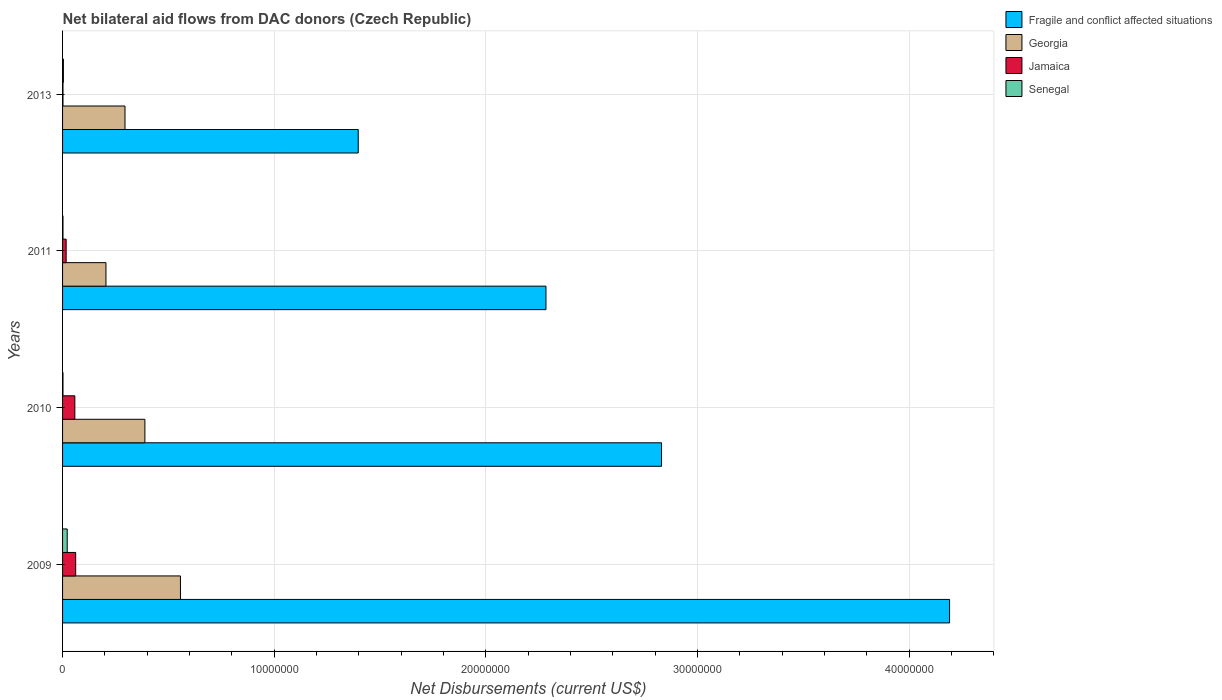How many groups of bars are there?
Provide a succinct answer. 4. How many bars are there on the 1st tick from the bottom?
Provide a short and direct response. 4. In how many cases, is the number of bars for a given year not equal to the number of legend labels?
Keep it short and to the point. 0. What is the net bilateral aid flows in Senegal in 2010?
Ensure brevity in your answer.  2.00e+04. Across all years, what is the maximum net bilateral aid flows in Fragile and conflict affected situations?
Your response must be concise. 4.19e+07. In which year was the net bilateral aid flows in Jamaica maximum?
Ensure brevity in your answer.  2009. In which year was the net bilateral aid flows in Jamaica minimum?
Your response must be concise. 2013. What is the total net bilateral aid flows in Georgia in the graph?
Give a very brief answer. 1.45e+07. What is the difference between the net bilateral aid flows in Senegal in 2009 and that in 2010?
Your answer should be compact. 2.00e+05. What is the difference between the net bilateral aid flows in Senegal in 2010 and the net bilateral aid flows in Fragile and conflict affected situations in 2013?
Provide a succinct answer. -1.40e+07. What is the average net bilateral aid flows in Georgia per year?
Keep it short and to the point. 3.62e+06. Is the difference between the net bilateral aid flows in Jamaica in 2009 and 2011 greater than the difference between the net bilateral aid flows in Senegal in 2009 and 2011?
Offer a very short reply. Yes. What is the difference between the highest and the second highest net bilateral aid flows in Fragile and conflict affected situations?
Offer a terse response. 1.36e+07. What is the difference between the highest and the lowest net bilateral aid flows in Fragile and conflict affected situations?
Give a very brief answer. 2.79e+07. In how many years, is the net bilateral aid flows in Georgia greater than the average net bilateral aid flows in Georgia taken over all years?
Provide a succinct answer. 2. Is the sum of the net bilateral aid flows in Fragile and conflict affected situations in 2010 and 2013 greater than the maximum net bilateral aid flows in Georgia across all years?
Give a very brief answer. Yes. Is it the case that in every year, the sum of the net bilateral aid flows in Fragile and conflict affected situations and net bilateral aid flows in Senegal is greater than the sum of net bilateral aid flows in Georgia and net bilateral aid flows in Jamaica?
Offer a terse response. Yes. What does the 3rd bar from the top in 2010 represents?
Ensure brevity in your answer.  Georgia. What does the 3rd bar from the bottom in 2009 represents?
Make the answer very short. Jamaica. Does the graph contain any zero values?
Ensure brevity in your answer.  No. How many legend labels are there?
Offer a very short reply. 4. How are the legend labels stacked?
Ensure brevity in your answer.  Vertical. What is the title of the graph?
Provide a succinct answer. Net bilateral aid flows from DAC donors (Czech Republic). Does "Middle East & North Africa (developing only)" appear as one of the legend labels in the graph?
Make the answer very short. No. What is the label or title of the X-axis?
Offer a very short reply. Net Disbursements (current US$). What is the label or title of the Y-axis?
Your answer should be compact. Years. What is the Net Disbursements (current US$) of Fragile and conflict affected situations in 2009?
Keep it short and to the point. 4.19e+07. What is the Net Disbursements (current US$) of Georgia in 2009?
Your answer should be compact. 5.57e+06. What is the Net Disbursements (current US$) of Jamaica in 2009?
Keep it short and to the point. 6.20e+05. What is the Net Disbursements (current US$) of Senegal in 2009?
Ensure brevity in your answer.  2.20e+05. What is the Net Disbursements (current US$) in Fragile and conflict affected situations in 2010?
Offer a terse response. 2.83e+07. What is the Net Disbursements (current US$) in Georgia in 2010?
Offer a terse response. 3.89e+06. What is the Net Disbursements (current US$) of Jamaica in 2010?
Your answer should be compact. 5.80e+05. What is the Net Disbursements (current US$) in Fragile and conflict affected situations in 2011?
Ensure brevity in your answer.  2.28e+07. What is the Net Disbursements (current US$) in Georgia in 2011?
Give a very brief answer. 2.05e+06. What is the Net Disbursements (current US$) in Jamaica in 2011?
Ensure brevity in your answer.  1.70e+05. What is the Net Disbursements (current US$) in Senegal in 2011?
Your response must be concise. 2.00e+04. What is the Net Disbursements (current US$) of Fragile and conflict affected situations in 2013?
Give a very brief answer. 1.40e+07. What is the Net Disbursements (current US$) in Georgia in 2013?
Ensure brevity in your answer.  2.95e+06. What is the Net Disbursements (current US$) in Jamaica in 2013?
Your response must be concise. 2.00e+04. What is the Net Disbursements (current US$) in Senegal in 2013?
Provide a short and direct response. 4.00e+04. Across all years, what is the maximum Net Disbursements (current US$) of Fragile and conflict affected situations?
Make the answer very short. 4.19e+07. Across all years, what is the maximum Net Disbursements (current US$) of Georgia?
Provide a succinct answer. 5.57e+06. Across all years, what is the maximum Net Disbursements (current US$) in Jamaica?
Give a very brief answer. 6.20e+05. Across all years, what is the maximum Net Disbursements (current US$) in Senegal?
Provide a succinct answer. 2.20e+05. Across all years, what is the minimum Net Disbursements (current US$) of Fragile and conflict affected situations?
Your answer should be compact. 1.40e+07. Across all years, what is the minimum Net Disbursements (current US$) in Georgia?
Provide a short and direct response. 2.05e+06. Across all years, what is the minimum Net Disbursements (current US$) of Senegal?
Your answer should be compact. 2.00e+04. What is the total Net Disbursements (current US$) in Fragile and conflict affected situations in the graph?
Offer a very short reply. 1.07e+08. What is the total Net Disbursements (current US$) in Georgia in the graph?
Your response must be concise. 1.45e+07. What is the total Net Disbursements (current US$) of Jamaica in the graph?
Offer a very short reply. 1.39e+06. What is the difference between the Net Disbursements (current US$) in Fragile and conflict affected situations in 2009 and that in 2010?
Offer a terse response. 1.36e+07. What is the difference between the Net Disbursements (current US$) in Georgia in 2009 and that in 2010?
Offer a very short reply. 1.68e+06. What is the difference between the Net Disbursements (current US$) in Fragile and conflict affected situations in 2009 and that in 2011?
Ensure brevity in your answer.  1.91e+07. What is the difference between the Net Disbursements (current US$) in Georgia in 2009 and that in 2011?
Offer a very short reply. 3.52e+06. What is the difference between the Net Disbursements (current US$) in Fragile and conflict affected situations in 2009 and that in 2013?
Provide a succinct answer. 2.79e+07. What is the difference between the Net Disbursements (current US$) in Georgia in 2009 and that in 2013?
Provide a short and direct response. 2.62e+06. What is the difference between the Net Disbursements (current US$) in Senegal in 2009 and that in 2013?
Offer a very short reply. 1.80e+05. What is the difference between the Net Disbursements (current US$) of Fragile and conflict affected situations in 2010 and that in 2011?
Your answer should be very brief. 5.46e+06. What is the difference between the Net Disbursements (current US$) in Georgia in 2010 and that in 2011?
Provide a succinct answer. 1.84e+06. What is the difference between the Net Disbursements (current US$) in Senegal in 2010 and that in 2011?
Give a very brief answer. 0. What is the difference between the Net Disbursements (current US$) in Fragile and conflict affected situations in 2010 and that in 2013?
Offer a terse response. 1.43e+07. What is the difference between the Net Disbursements (current US$) of Georgia in 2010 and that in 2013?
Give a very brief answer. 9.40e+05. What is the difference between the Net Disbursements (current US$) of Jamaica in 2010 and that in 2013?
Provide a succinct answer. 5.60e+05. What is the difference between the Net Disbursements (current US$) in Fragile and conflict affected situations in 2011 and that in 2013?
Make the answer very short. 8.87e+06. What is the difference between the Net Disbursements (current US$) of Georgia in 2011 and that in 2013?
Keep it short and to the point. -9.00e+05. What is the difference between the Net Disbursements (current US$) in Fragile and conflict affected situations in 2009 and the Net Disbursements (current US$) in Georgia in 2010?
Ensure brevity in your answer.  3.80e+07. What is the difference between the Net Disbursements (current US$) of Fragile and conflict affected situations in 2009 and the Net Disbursements (current US$) of Jamaica in 2010?
Offer a terse response. 4.13e+07. What is the difference between the Net Disbursements (current US$) of Fragile and conflict affected situations in 2009 and the Net Disbursements (current US$) of Senegal in 2010?
Your answer should be very brief. 4.19e+07. What is the difference between the Net Disbursements (current US$) of Georgia in 2009 and the Net Disbursements (current US$) of Jamaica in 2010?
Keep it short and to the point. 4.99e+06. What is the difference between the Net Disbursements (current US$) of Georgia in 2009 and the Net Disbursements (current US$) of Senegal in 2010?
Offer a very short reply. 5.55e+06. What is the difference between the Net Disbursements (current US$) of Fragile and conflict affected situations in 2009 and the Net Disbursements (current US$) of Georgia in 2011?
Your answer should be very brief. 3.99e+07. What is the difference between the Net Disbursements (current US$) of Fragile and conflict affected situations in 2009 and the Net Disbursements (current US$) of Jamaica in 2011?
Provide a succinct answer. 4.17e+07. What is the difference between the Net Disbursements (current US$) in Fragile and conflict affected situations in 2009 and the Net Disbursements (current US$) in Senegal in 2011?
Provide a short and direct response. 4.19e+07. What is the difference between the Net Disbursements (current US$) in Georgia in 2009 and the Net Disbursements (current US$) in Jamaica in 2011?
Your response must be concise. 5.40e+06. What is the difference between the Net Disbursements (current US$) in Georgia in 2009 and the Net Disbursements (current US$) in Senegal in 2011?
Provide a succinct answer. 5.55e+06. What is the difference between the Net Disbursements (current US$) in Jamaica in 2009 and the Net Disbursements (current US$) in Senegal in 2011?
Your response must be concise. 6.00e+05. What is the difference between the Net Disbursements (current US$) in Fragile and conflict affected situations in 2009 and the Net Disbursements (current US$) in Georgia in 2013?
Keep it short and to the point. 3.90e+07. What is the difference between the Net Disbursements (current US$) in Fragile and conflict affected situations in 2009 and the Net Disbursements (current US$) in Jamaica in 2013?
Provide a short and direct response. 4.19e+07. What is the difference between the Net Disbursements (current US$) in Fragile and conflict affected situations in 2009 and the Net Disbursements (current US$) in Senegal in 2013?
Provide a succinct answer. 4.19e+07. What is the difference between the Net Disbursements (current US$) in Georgia in 2009 and the Net Disbursements (current US$) in Jamaica in 2013?
Give a very brief answer. 5.55e+06. What is the difference between the Net Disbursements (current US$) of Georgia in 2009 and the Net Disbursements (current US$) of Senegal in 2013?
Ensure brevity in your answer.  5.53e+06. What is the difference between the Net Disbursements (current US$) in Jamaica in 2009 and the Net Disbursements (current US$) in Senegal in 2013?
Provide a succinct answer. 5.80e+05. What is the difference between the Net Disbursements (current US$) in Fragile and conflict affected situations in 2010 and the Net Disbursements (current US$) in Georgia in 2011?
Ensure brevity in your answer.  2.62e+07. What is the difference between the Net Disbursements (current US$) in Fragile and conflict affected situations in 2010 and the Net Disbursements (current US$) in Jamaica in 2011?
Ensure brevity in your answer.  2.81e+07. What is the difference between the Net Disbursements (current US$) in Fragile and conflict affected situations in 2010 and the Net Disbursements (current US$) in Senegal in 2011?
Provide a short and direct response. 2.83e+07. What is the difference between the Net Disbursements (current US$) of Georgia in 2010 and the Net Disbursements (current US$) of Jamaica in 2011?
Your answer should be compact. 3.72e+06. What is the difference between the Net Disbursements (current US$) of Georgia in 2010 and the Net Disbursements (current US$) of Senegal in 2011?
Your answer should be very brief. 3.87e+06. What is the difference between the Net Disbursements (current US$) in Jamaica in 2010 and the Net Disbursements (current US$) in Senegal in 2011?
Keep it short and to the point. 5.60e+05. What is the difference between the Net Disbursements (current US$) of Fragile and conflict affected situations in 2010 and the Net Disbursements (current US$) of Georgia in 2013?
Provide a short and direct response. 2.54e+07. What is the difference between the Net Disbursements (current US$) in Fragile and conflict affected situations in 2010 and the Net Disbursements (current US$) in Jamaica in 2013?
Your response must be concise. 2.83e+07. What is the difference between the Net Disbursements (current US$) of Fragile and conflict affected situations in 2010 and the Net Disbursements (current US$) of Senegal in 2013?
Offer a terse response. 2.83e+07. What is the difference between the Net Disbursements (current US$) of Georgia in 2010 and the Net Disbursements (current US$) of Jamaica in 2013?
Offer a very short reply. 3.87e+06. What is the difference between the Net Disbursements (current US$) of Georgia in 2010 and the Net Disbursements (current US$) of Senegal in 2013?
Offer a terse response. 3.85e+06. What is the difference between the Net Disbursements (current US$) of Jamaica in 2010 and the Net Disbursements (current US$) of Senegal in 2013?
Give a very brief answer. 5.40e+05. What is the difference between the Net Disbursements (current US$) in Fragile and conflict affected situations in 2011 and the Net Disbursements (current US$) in Georgia in 2013?
Your answer should be compact. 1.99e+07. What is the difference between the Net Disbursements (current US$) of Fragile and conflict affected situations in 2011 and the Net Disbursements (current US$) of Jamaica in 2013?
Ensure brevity in your answer.  2.28e+07. What is the difference between the Net Disbursements (current US$) in Fragile and conflict affected situations in 2011 and the Net Disbursements (current US$) in Senegal in 2013?
Offer a terse response. 2.28e+07. What is the difference between the Net Disbursements (current US$) of Georgia in 2011 and the Net Disbursements (current US$) of Jamaica in 2013?
Provide a succinct answer. 2.03e+06. What is the difference between the Net Disbursements (current US$) in Georgia in 2011 and the Net Disbursements (current US$) in Senegal in 2013?
Make the answer very short. 2.01e+06. What is the average Net Disbursements (current US$) of Fragile and conflict affected situations per year?
Offer a terse response. 2.68e+07. What is the average Net Disbursements (current US$) in Georgia per year?
Your answer should be compact. 3.62e+06. What is the average Net Disbursements (current US$) in Jamaica per year?
Offer a very short reply. 3.48e+05. What is the average Net Disbursements (current US$) of Senegal per year?
Provide a short and direct response. 7.50e+04. In the year 2009, what is the difference between the Net Disbursements (current US$) in Fragile and conflict affected situations and Net Disbursements (current US$) in Georgia?
Ensure brevity in your answer.  3.63e+07. In the year 2009, what is the difference between the Net Disbursements (current US$) of Fragile and conflict affected situations and Net Disbursements (current US$) of Jamaica?
Provide a succinct answer. 4.13e+07. In the year 2009, what is the difference between the Net Disbursements (current US$) of Fragile and conflict affected situations and Net Disbursements (current US$) of Senegal?
Offer a very short reply. 4.17e+07. In the year 2009, what is the difference between the Net Disbursements (current US$) of Georgia and Net Disbursements (current US$) of Jamaica?
Make the answer very short. 4.95e+06. In the year 2009, what is the difference between the Net Disbursements (current US$) in Georgia and Net Disbursements (current US$) in Senegal?
Make the answer very short. 5.35e+06. In the year 2010, what is the difference between the Net Disbursements (current US$) in Fragile and conflict affected situations and Net Disbursements (current US$) in Georgia?
Provide a short and direct response. 2.44e+07. In the year 2010, what is the difference between the Net Disbursements (current US$) in Fragile and conflict affected situations and Net Disbursements (current US$) in Jamaica?
Ensure brevity in your answer.  2.77e+07. In the year 2010, what is the difference between the Net Disbursements (current US$) of Fragile and conflict affected situations and Net Disbursements (current US$) of Senegal?
Your response must be concise. 2.83e+07. In the year 2010, what is the difference between the Net Disbursements (current US$) of Georgia and Net Disbursements (current US$) of Jamaica?
Provide a short and direct response. 3.31e+06. In the year 2010, what is the difference between the Net Disbursements (current US$) in Georgia and Net Disbursements (current US$) in Senegal?
Provide a short and direct response. 3.87e+06. In the year 2010, what is the difference between the Net Disbursements (current US$) of Jamaica and Net Disbursements (current US$) of Senegal?
Give a very brief answer. 5.60e+05. In the year 2011, what is the difference between the Net Disbursements (current US$) of Fragile and conflict affected situations and Net Disbursements (current US$) of Georgia?
Your answer should be very brief. 2.08e+07. In the year 2011, what is the difference between the Net Disbursements (current US$) of Fragile and conflict affected situations and Net Disbursements (current US$) of Jamaica?
Your response must be concise. 2.27e+07. In the year 2011, what is the difference between the Net Disbursements (current US$) of Fragile and conflict affected situations and Net Disbursements (current US$) of Senegal?
Provide a succinct answer. 2.28e+07. In the year 2011, what is the difference between the Net Disbursements (current US$) in Georgia and Net Disbursements (current US$) in Jamaica?
Make the answer very short. 1.88e+06. In the year 2011, what is the difference between the Net Disbursements (current US$) in Georgia and Net Disbursements (current US$) in Senegal?
Your answer should be very brief. 2.03e+06. In the year 2013, what is the difference between the Net Disbursements (current US$) of Fragile and conflict affected situations and Net Disbursements (current US$) of Georgia?
Keep it short and to the point. 1.10e+07. In the year 2013, what is the difference between the Net Disbursements (current US$) of Fragile and conflict affected situations and Net Disbursements (current US$) of Jamaica?
Provide a succinct answer. 1.40e+07. In the year 2013, what is the difference between the Net Disbursements (current US$) in Fragile and conflict affected situations and Net Disbursements (current US$) in Senegal?
Your answer should be very brief. 1.39e+07. In the year 2013, what is the difference between the Net Disbursements (current US$) of Georgia and Net Disbursements (current US$) of Jamaica?
Give a very brief answer. 2.93e+06. In the year 2013, what is the difference between the Net Disbursements (current US$) of Georgia and Net Disbursements (current US$) of Senegal?
Provide a succinct answer. 2.91e+06. In the year 2013, what is the difference between the Net Disbursements (current US$) in Jamaica and Net Disbursements (current US$) in Senegal?
Provide a short and direct response. -2.00e+04. What is the ratio of the Net Disbursements (current US$) of Fragile and conflict affected situations in 2009 to that in 2010?
Your answer should be compact. 1.48. What is the ratio of the Net Disbursements (current US$) in Georgia in 2009 to that in 2010?
Your answer should be compact. 1.43. What is the ratio of the Net Disbursements (current US$) of Jamaica in 2009 to that in 2010?
Provide a short and direct response. 1.07. What is the ratio of the Net Disbursements (current US$) in Senegal in 2009 to that in 2010?
Keep it short and to the point. 11. What is the ratio of the Net Disbursements (current US$) of Fragile and conflict affected situations in 2009 to that in 2011?
Offer a terse response. 1.83. What is the ratio of the Net Disbursements (current US$) in Georgia in 2009 to that in 2011?
Offer a very short reply. 2.72. What is the ratio of the Net Disbursements (current US$) in Jamaica in 2009 to that in 2011?
Provide a succinct answer. 3.65. What is the ratio of the Net Disbursements (current US$) in Fragile and conflict affected situations in 2009 to that in 2013?
Offer a terse response. 3. What is the ratio of the Net Disbursements (current US$) in Georgia in 2009 to that in 2013?
Provide a short and direct response. 1.89. What is the ratio of the Net Disbursements (current US$) in Jamaica in 2009 to that in 2013?
Give a very brief answer. 31. What is the ratio of the Net Disbursements (current US$) in Senegal in 2009 to that in 2013?
Ensure brevity in your answer.  5.5. What is the ratio of the Net Disbursements (current US$) of Fragile and conflict affected situations in 2010 to that in 2011?
Provide a short and direct response. 1.24. What is the ratio of the Net Disbursements (current US$) in Georgia in 2010 to that in 2011?
Ensure brevity in your answer.  1.9. What is the ratio of the Net Disbursements (current US$) of Jamaica in 2010 to that in 2011?
Ensure brevity in your answer.  3.41. What is the ratio of the Net Disbursements (current US$) in Senegal in 2010 to that in 2011?
Make the answer very short. 1. What is the ratio of the Net Disbursements (current US$) of Fragile and conflict affected situations in 2010 to that in 2013?
Offer a very short reply. 2.03. What is the ratio of the Net Disbursements (current US$) in Georgia in 2010 to that in 2013?
Ensure brevity in your answer.  1.32. What is the ratio of the Net Disbursements (current US$) in Senegal in 2010 to that in 2013?
Your response must be concise. 0.5. What is the ratio of the Net Disbursements (current US$) in Fragile and conflict affected situations in 2011 to that in 2013?
Ensure brevity in your answer.  1.63. What is the ratio of the Net Disbursements (current US$) in Georgia in 2011 to that in 2013?
Your response must be concise. 0.69. What is the ratio of the Net Disbursements (current US$) in Jamaica in 2011 to that in 2013?
Keep it short and to the point. 8.5. What is the difference between the highest and the second highest Net Disbursements (current US$) in Fragile and conflict affected situations?
Your answer should be compact. 1.36e+07. What is the difference between the highest and the second highest Net Disbursements (current US$) in Georgia?
Provide a succinct answer. 1.68e+06. What is the difference between the highest and the second highest Net Disbursements (current US$) in Jamaica?
Offer a very short reply. 4.00e+04. What is the difference between the highest and the lowest Net Disbursements (current US$) in Fragile and conflict affected situations?
Provide a short and direct response. 2.79e+07. What is the difference between the highest and the lowest Net Disbursements (current US$) of Georgia?
Give a very brief answer. 3.52e+06. 